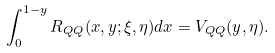Convert formula to latex. <formula><loc_0><loc_0><loc_500><loc_500>\int _ { 0 } ^ { 1 - y } R _ { Q Q } ( x , y ; \xi , \eta ) d x = V _ { Q Q } ( y , \eta ) .</formula> 